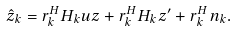Convert formula to latex. <formula><loc_0><loc_0><loc_500><loc_500>\hat { z } _ { k } = { r } _ { k } ^ { H } { H } _ { k } { u } z + { r } _ { k } ^ { H } { H } _ { k } { z ^ { \prime } } + { r } _ { k } ^ { H } { n } _ { k } .</formula> 